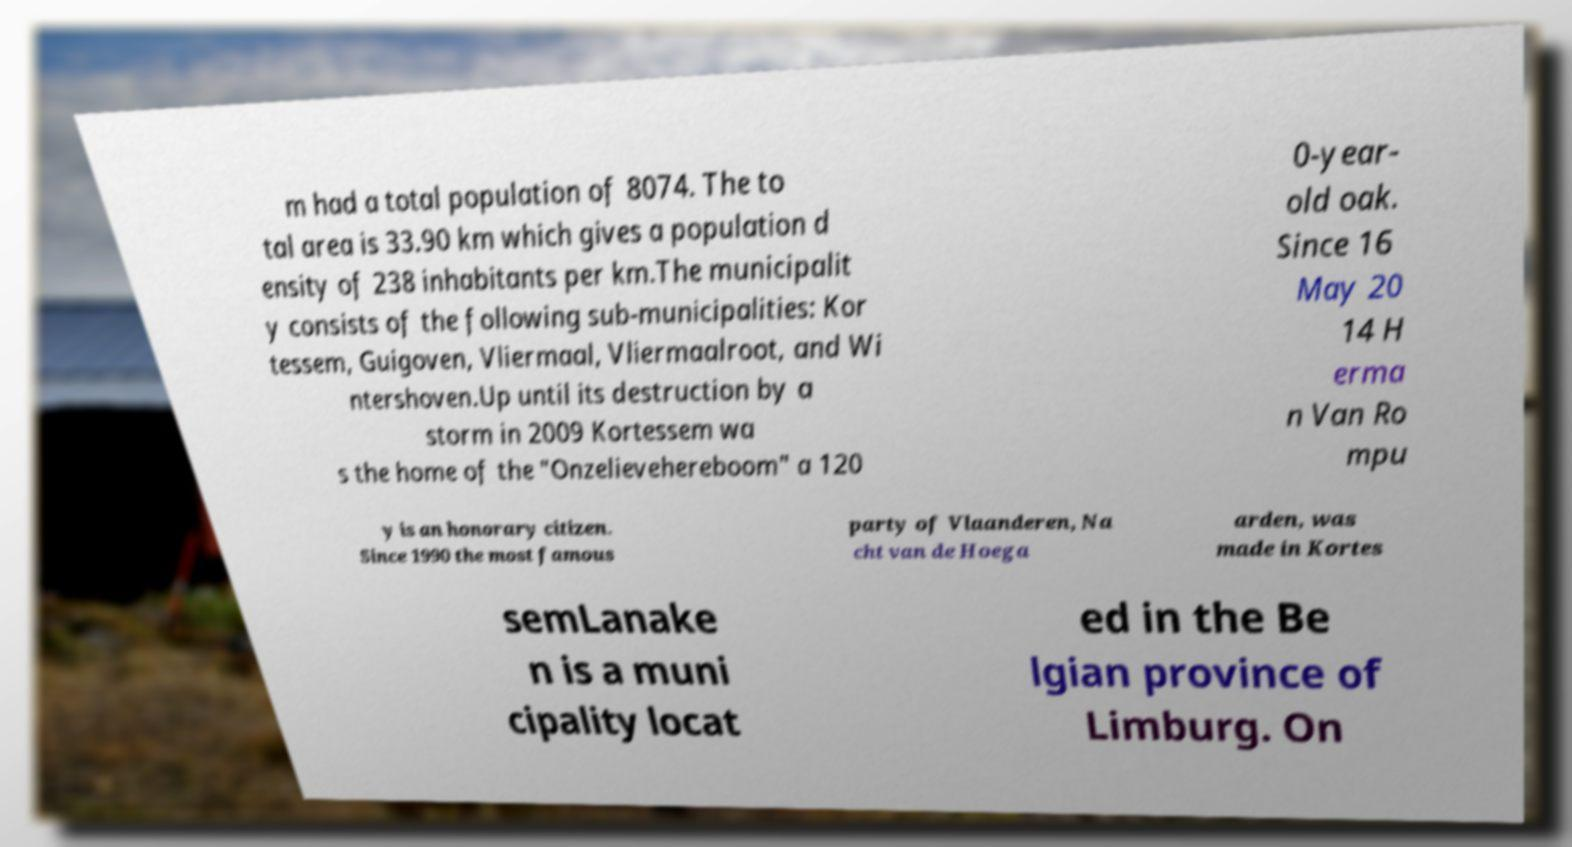What messages or text are displayed in this image? I need them in a readable, typed format. m had a total population of 8074. The to tal area is 33.90 km which gives a population d ensity of 238 inhabitants per km.The municipalit y consists of the following sub-municipalities: Kor tessem, Guigoven, Vliermaal, Vliermaalroot, and Wi ntershoven.Up until its destruction by a storm in 2009 Kortessem wa s the home of the "Onzelievehereboom" a 120 0-year- old oak. Since 16 May 20 14 H erma n Van Ro mpu y is an honorary citizen. Since 1990 the most famous party of Vlaanderen, Na cht van de Hoega arden, was made in Kortes semLanake n is a muni cipality locat ed in the Be lgian province of Limburg. On 